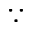Convert formula to latex. <formula><loc_0><loc_0><loc_500><loc_500>\because</formula> 